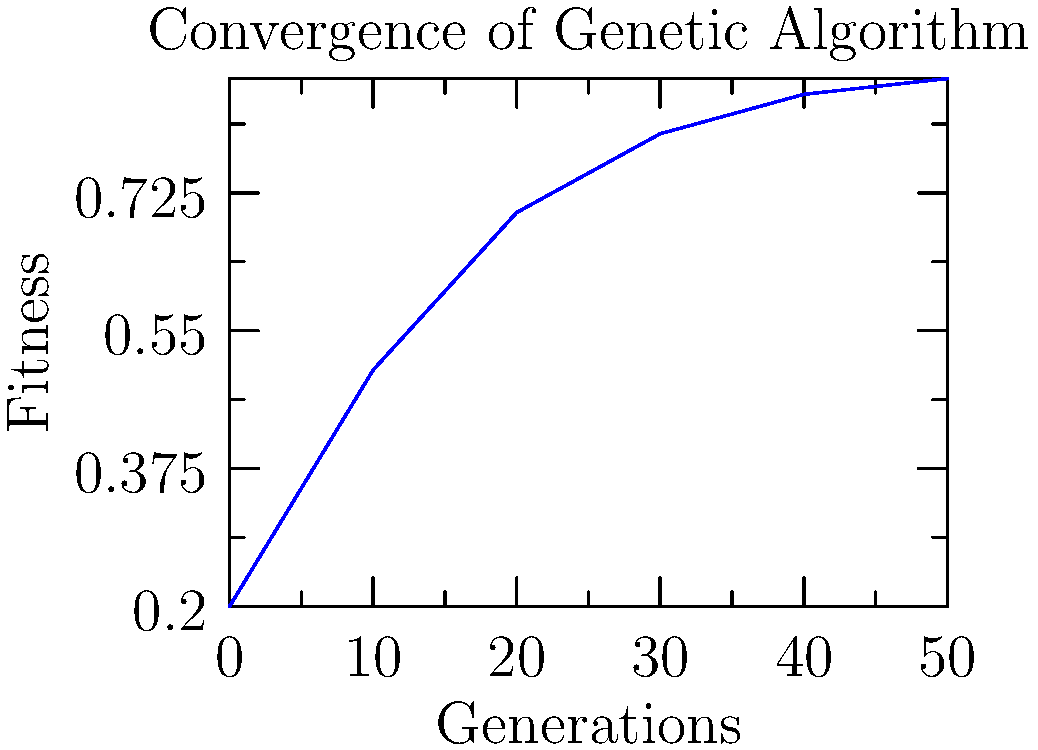In the graph showing the convergence of a genetic algorithm, what phenomenon is observed in the later generations, and how does this relate to the concept of premature convergence in evolutionary algorithms? 1. Observe the graph: The x-axis represents generations, and the y-axis represents fitness.

2. Analyze the curve:
   - Initial steep increase in fitness (generations 0-20)
   - Gradual slowing of improvement (generations 20-40)
   - Plateauing effect in later generations (40-50)

3. Interpret the plateauing:
   - Indicates algorithm is converging on a solution
   - Fitness improvements become smaller and less frequent

4. Relate to premature convergence:
   - Premature convergence occurs when the algorithm settles on a suboptimal solution too quickly
   - In this case, the gradual plateauing suggests a more natural convergence

5. Consider implications:
   - Plateauing might indicate reaching global optimum
   - Or, it could suggest the need for increased genetic diversity or modified selection pressure

6. Conclusion:
   The phenomenon observed is a plateauing of fitness in later generations, indicating convergence. This gradual plateauing is less likely to represent premature convergence, but rather a more desirable, natural convergence towards an optimal solution.
Answer: Fitness plateauing in later generations, indicating natural convergence rather than premature convergence. 